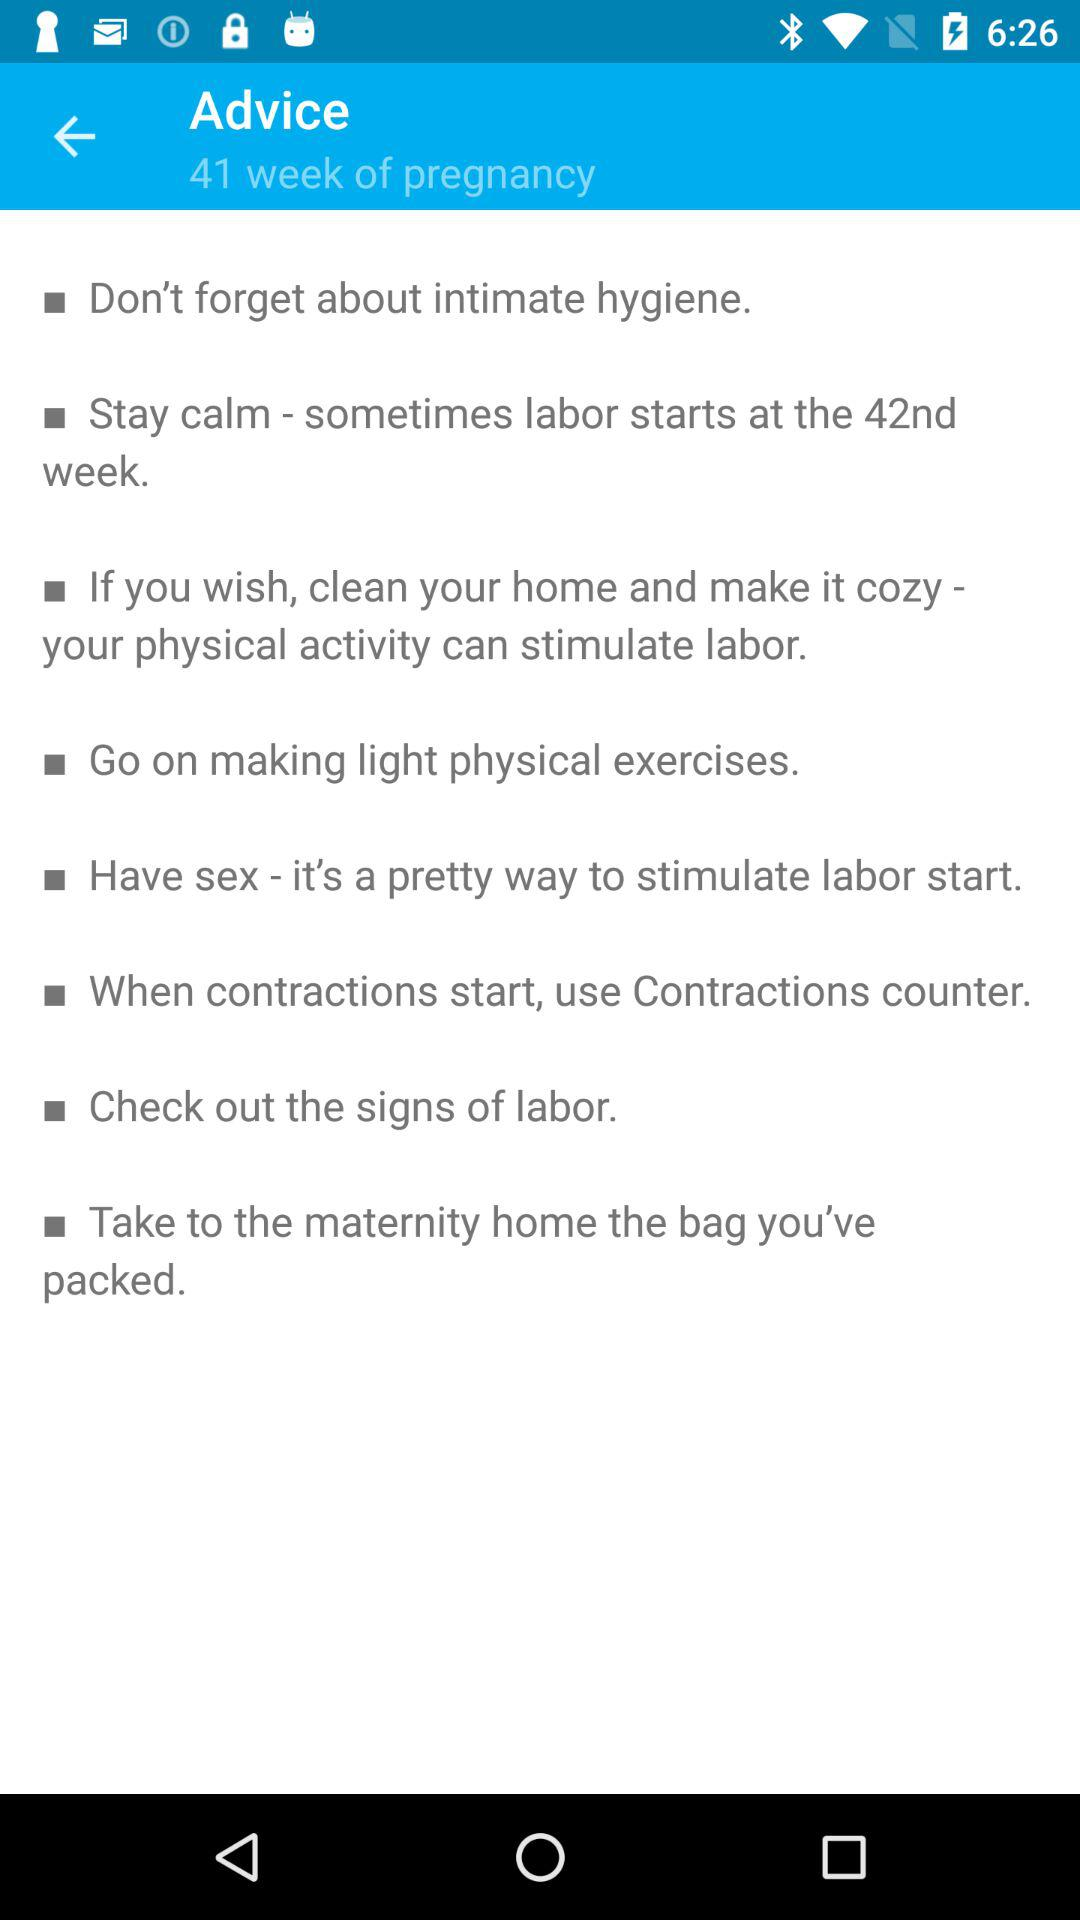What is the advice for 41 week of pregnancy? The advice is "Don't forget about intimate hygiene", "Stay calm - sometimes labor starts at the 42nd week", "If you wish, clean your home and make it cozy - your physical activity can stimulate labor", "Go on making light physical exercises", "Have sex - it's a pretty way to stimulate labor start", "When contractions start, use Contractions counter", "Check out the signs of labor" and "Take to the maternity home the bag you've packed". 